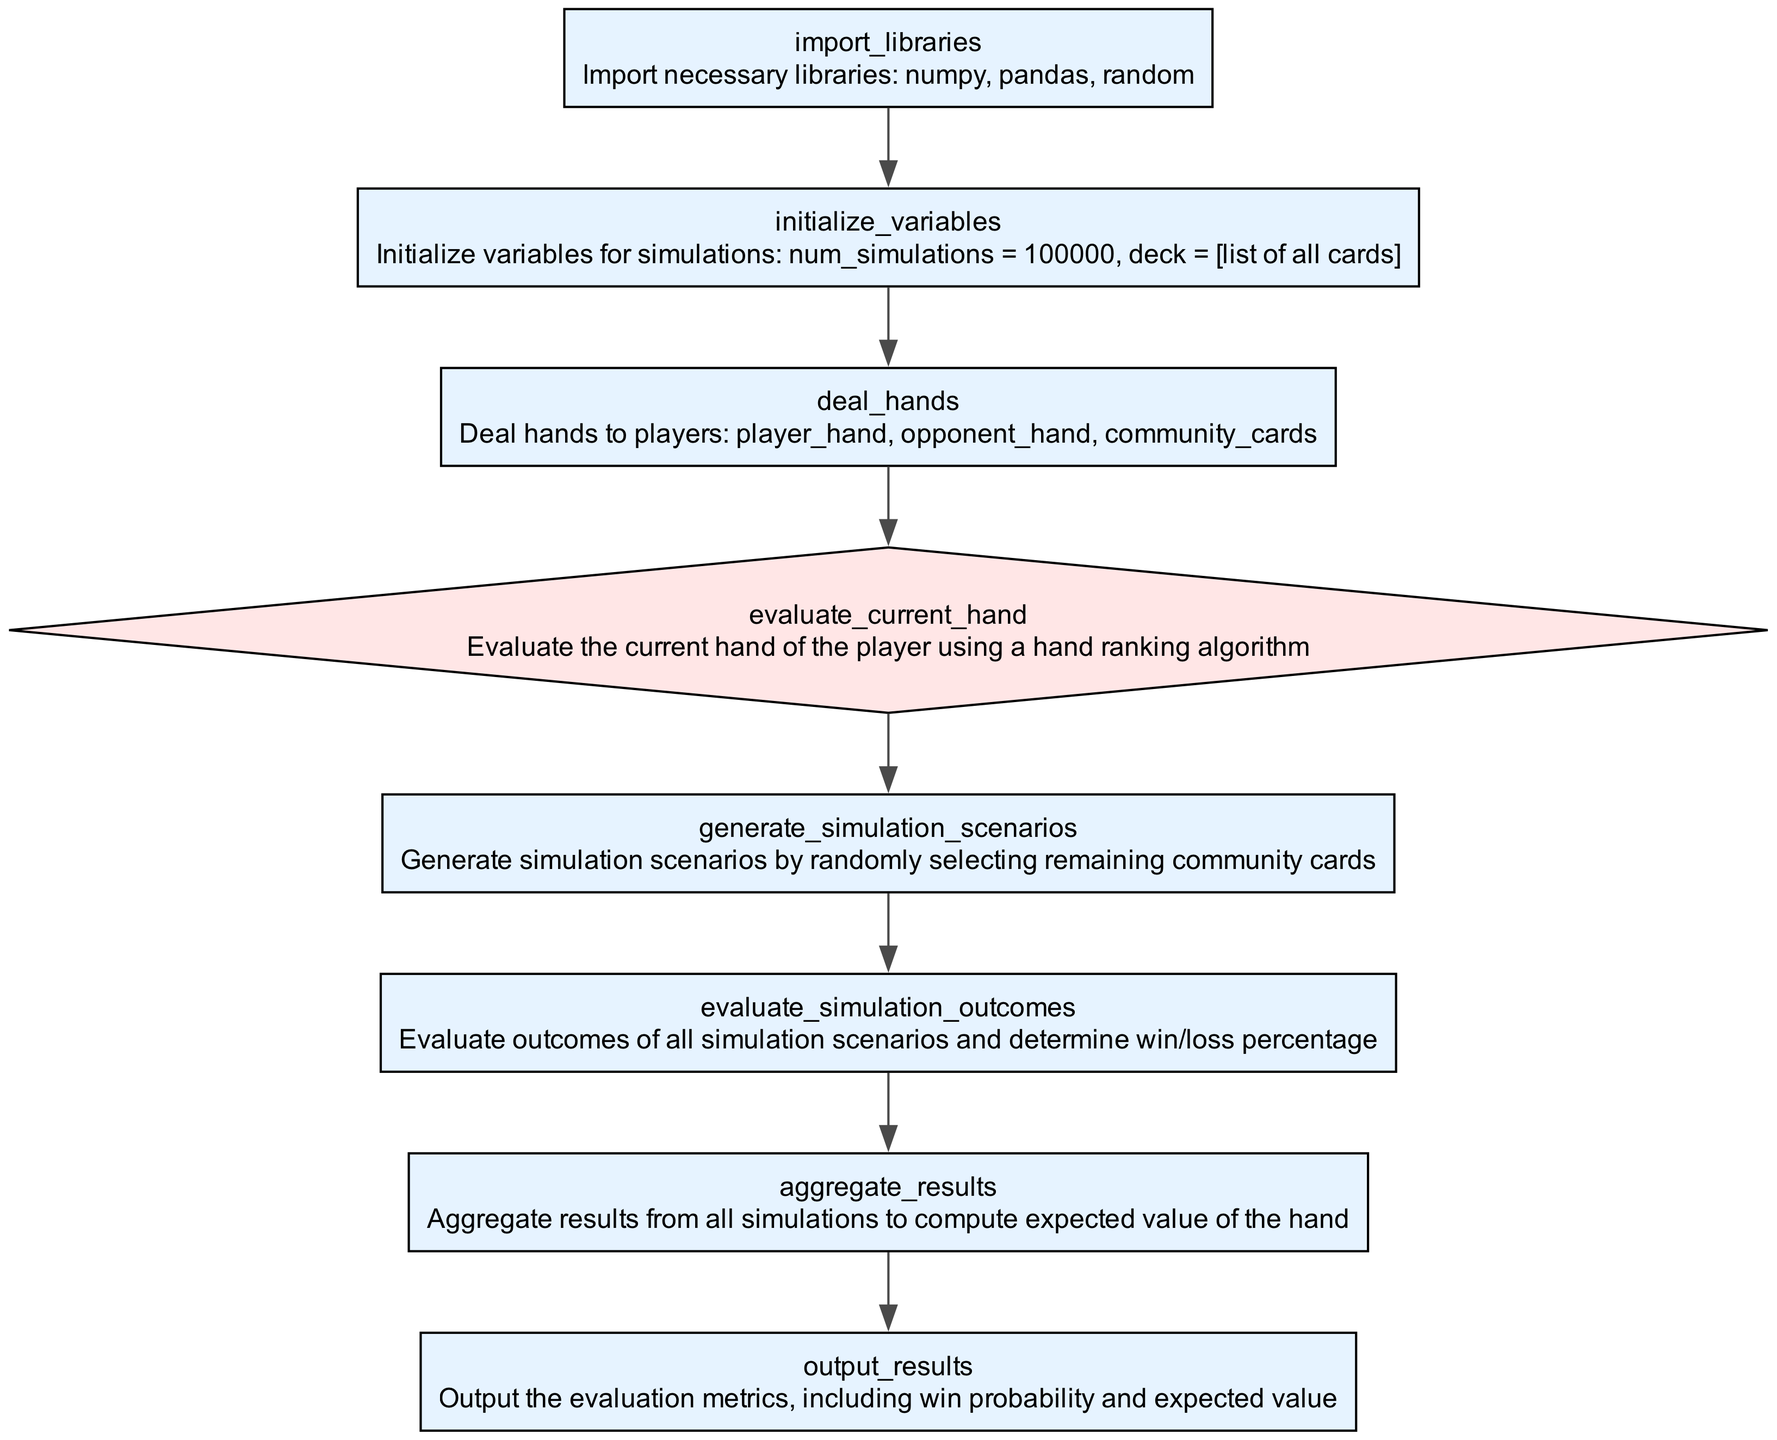what is the first operation in the flowchart? The first operation in the flowchart is "import_libraries", which is indicated as the initial node before any other operations.
Answer: import_libraries how many decision nodes are present in the diagram? There is one decision node in the flowchart, which is "evaluate_current_hand". This can be counted by looking for the node with a diamond shape.
Answer: one what operation follows the evaluation of the current hand? After "evaluate_current_hand", the next operation is "generate_simulation_scenarios". This is determined by following the directed edge leading from the decision node to the next operation.
Answer: generate_simulation_scenarios what is the last operation in the flowchart? The last operation in the flowchart is "output_results". This is located at the end of the sequence of nodes, indicating the final step of the process.
Answer: output_results what is the relationship between "deal_hands" and "evaluate_simulation_outcomes"? "deal_hands" is followed directly by "evaluate_simulation_outcomes" in the sequence of operations, indicating that hands are dealt before evaluating simulation outcomes.
Answer: sequential how many operations exist before the decision point? There are four operations ("import_libraries", "initialize_variables", "deal_hands", "evaluate_current_hand") that occur before reaching the decision point. This can be counted from the start node up to the decision node.
Answer: four what is the purpose of "aggregate_results"? The purpose of "aggregate_results" is to compute the expected value of the hand based on the results from all simulations. This is derived from understanding the definitions provided in the nodes of the flowchart.
Answer: compute expected value what type of chart is this? This is a flowchart specifically representing the flow of a Python function for optimizing poker hand evaluation using Monte Carlo simulations. The structure and layout indicate it is not just a typical diagram but a flowchart of a process.
Answer: flowchart 